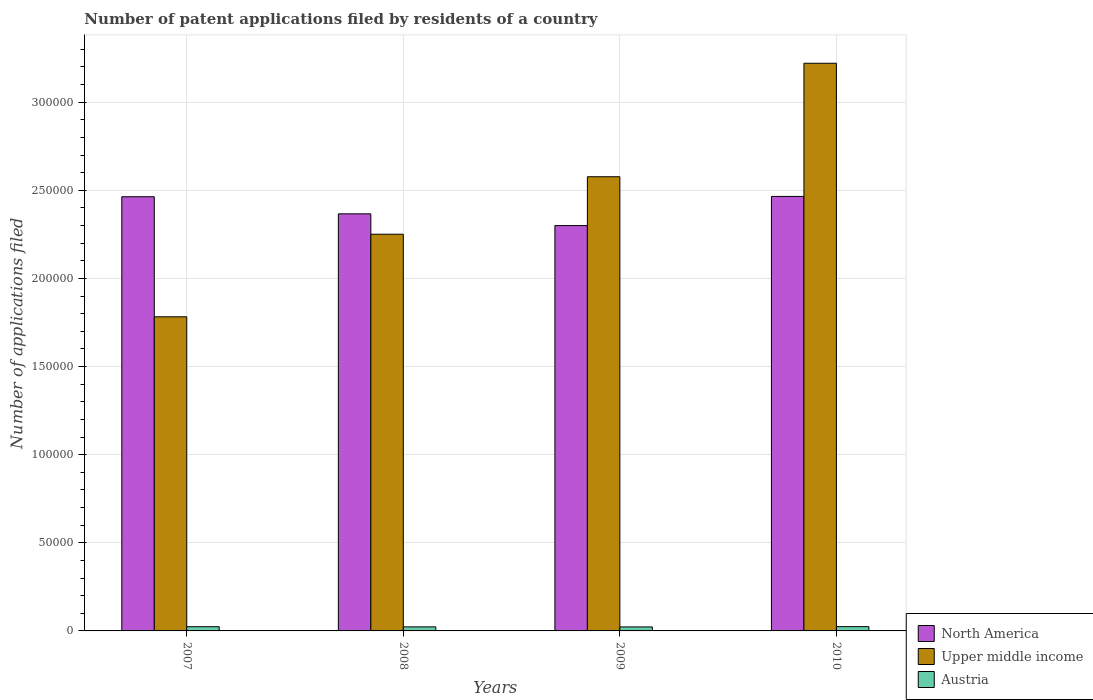Are the number of bars per tick equal to the number of legend labels?
Give a very brief answer. Yes. How many bars are there on the 3rd tick from the right?
Your answer should be compact. 3. What is the number of applications filed in Austria in 2008?
Make the answer very short. 2298. Across all years, what is the maximum number of applications filed in Austria?
Your answer should be compact. 2424. Across all years, what is the minimum number of applications filed in Upper middle income?
Ensure brevity in your answer.  1.78e+05. In which year was the number of applications filed in Austria minimum?
Keep it short and to the point. 2009. What is the total number of applications filed in Upper middle income in the graph?
Make the answer very short. 9.83e+05. What is the difference between the number of applications filed in Upper middle income in 2007 and that in 2010?
Give a very brief answer. -1.44e+05. What is the difference between the number of applications filed in Austria in 2008 and the number of applications filed in North America in 2009?
Ensure brevity in your answer.  -2.28e+05. What is the average number of applications filed in Upper middle income per year?
Provide a succinct answer. 2.46e+05. In the year 2008, what is the difference between the number of applications filed in Austria and number of applications filed in North America?
Provide a succinct answer. -2.34e+05. In how many years, is the number of applications filed in North America greater than 120000?
Give a very brief answer. 4. What is the ratio of the number of applications filed in Austria in 2008 to that in 2009?
Your answer should be very brief. 1.02. Is the number of applications filed in Austria in 2007 less than that in 2009?
Keep it short and to the point. No. What is the difference between the highest and the second highest number of applications filed in Austria?
Keep it short and to the point. 39. What is the difference between the highest and the lowest number of applications filed in Austria?
Your answer should be compact. 161. What does the 2nd bar from the left in 2010 represents?
Provide a succinct answer. Upper middle income. What does the 2nd bar from the right in 2007 represents?
Give a very brief answer. Upper middle income. Are all the bars in the graph horizontal?
Provide a succinct answer. No. What is the difference between two consecutive major ticks on the Y-axis?
Offer a very short reply. 5.00e+04. Are the values on the major ticks of Y-axis written in scientific E-notation?
Offer a very short reply. No. Does the graph contain grids?
Offer a terse response. Yes. Where does the legend appear in the graph?
Provide a short and direct response. Bottom right. What is the title of the graph?
Your answer should be very brief. Number of patent applications filed by residents of a country. Does "Uruguay" appear as one of the legend labels in the graph?
Provide a succinct answer. No. What is the label or title of the Y-axis?
Give a very brief answer. Number of applications filed. What is the Number of applications filed in North America in 2007?
Your answer should be compact. 2.46e+05. What is the Number of applications filed in Upper middle income in 2007?
Offer a terse response. 1.78e+05. What is the Number of applications filed of Austria in 2007?
Keep it short and to the point. 2385. What is the Number of applications filed of North America in 2008?
Offer a very short reply. 2.37e+05. What is the Number of applications filed of Upper middle income in 2008?
Your response must be concise. 2.25e+05. What is the Number of applications filed in Austria in 2008?
Keep it short and to the point. 2298. What is the Number of applications filed of North America in 2009?
Offer a very short reply. 2.30e+05. What is the Number of applications filed of Upper middle income in 2009?
Keep it short and to the point. 2.58e+05. What is the Number of applications filed in Austria in 2009?
Give a very brief answer. 2263. What is the Number of applications filed in North America in 2010?
Ensure brevity in your answer.  2.47e+05. What is the Number of applications filed in Upper middle income in 2010?
Your answer should be compact. 3.22e+05. What is the Number of applications filed of Austria in 2010?
Provide a succinct answer. 2424. Across all years, what is the maximum Number of applications filed in North America?
Make the answer very short. 2.47e+05. Across all years, what is the maximum Number of applications filed of Upper middle income?
Your answer should be very brief. 3.22e+05. Across all years, what is the maximum Number of applications filed in Austria?
Your answer should be very brief. 2424. Across all years, what is the minimum Number of applications filed in North America?
Your answer should be compact. 2.30e+05. Across all years, what is the minimum Number of applications filed of Upper middle income?
Provide a succinct answer. 1.78e+05. Across all years, what is the minimum Number of applications filed of Austria?
Your answer should be very brief. 2263. What is the total Number of applications filed in North America in the graph?
Make the answer very short. 9.60e+05. What is the total Number of applications filed of Upper middle income in the graph?
Your response must be concise. 9.83e+05. What is the total Number of applications filed of Austria in the graph?
Offer a terse response. 9370. What is the difference between the Number of applications filed of North America in 2007 and that in 2008?
Give a very brief answer. 9696. What is the difference between the Number of applications filed in Upper middle income in 2007 and that in 2008?
Your answer should be compact. -4.68e+04. What is the difference between the Number of applications filed of North America in 2007 and that in 2009?
Your answer should be very brief. 1.64e+04. What is the difference between the Number of applications filed in Upper middle income in 2007 and that in 2009?
Your answer should be very brief. -7.95e+04. What is the difference between the Number of applications filed in Austria in 2007 and that in 2009?
Provide a succinct answer. 122. What is the difference between the Number of applications filed in North America in 2007 and that in 2010?
Your answer should be very brief. -182. What is the difference between the Number of applications filed in Upper middle income in 2007 and that in 2010?
Your answer should be very brief. -1.44e+05. What is the difference between the Number of applications filed in Austria in 2007 and that in 2010?
Offer a very short reply. -39. What is the difference between the Number of applications filed in North America in 2008 and that in 2009?
Offer a very short reply. 6670. What is the difference between the Number of applications filed in Upper middle income in 2008 and that in 2009?
Your answer should be compact. -3.26e+04. What is the difference between the Number of applications filed of North America in 2008 and that in 2010?
Your response must be concise. -9878. What is the difference between the Number of applications filed of Upper middle income in 2008 and that in 2010?
Offer a terse response. -9.70e+04. What is the difference between the Number of applications filed of Austria in 2008 and that in 2010?
Offer a very short reply. -126. What is the difference between the Number of applications filed in North America in 2009 and that in 2010?
Your answer should be compact. -1.65e+04. What is the difference between the Number of applications filed in Upper middle income in 2009 and that in 2010?
Offer a terse response. -6.44e+04. What is the difference between the Number of applications filed of Austria in 2009 and that in 2010?
Offer a terse response. -161. What is the difference between the Number of applications filed of North America in 2007 and the Number of applications filed of Upper middle income in 2008?
Your answer should be very brief. 2.13e+04. What is the difference between the Number of applications filed of North America in 2007 and the Number of applications filed of Austria in 2008?
Provide a short and direct response. 2.44e+05. What is the difference between the Number of applications filed in Upper middle income in 2007 and the Number of applications filed in Austria in 2008?
Provide a short and direct response. 1.76e+05. What is the difference between the Number of applications filed of North America in 2007 and the Number of applications filed of Upper middle income in 2009?
Provide a short and direct response. -1.14e+04. What is the difference between the Number of applications filed in North America in 2007 and the Number of applications filed in Austria in 2009?
Give a very brief answer. 2.44e+05. What is the difference between the Number of applications filed in Upper middle income in 2007 and the Number of applications filed in Austria in 2009?
Keep it short and to the point. 1.76e+05. What is the difference between the Number of applications filed in North America in 2007 and the Number of applications filed in Upper middle income in 2010?
Provide a short and direct response. -7.57e+04. What is the difference between the Number of applications filed of North America in 2007 and the Number of applications filed of Austria in 2010?
Ensure brevity in your answer.  2.44e+05. What is the difference between the Number of applications filed of Upper middle income in 2007 and the Number of applications filed of Austria in 2010?
Give a very brief answer. 1.76e+05. What is the difference between the Number of applications filed of North America in 2008 and the Number of applications filed of Upper middle income in 2009?
Give a very brief answer. -2.10e+04. What is the difference between the Number of applications filed in North America in 2008 and the Number of applications filed in Austria in 2009?
Your response must be concise. 2.34e+05. What is the difference between the Number of applications filed of Upper middle income in 2008 and the Number of applications filed of Austria in 2009?
Make the answer very short. 2.23e+05. What is the difference between the Number of applications filed of North America in 2008 and the Number of applications filed of Upper middle income in 2010?
Provide a short and direct response. -8.54e+04. What is the difference between the Number of applications filed of North America in 2008 and the Number of applications filed of Austria in 2010?
Make the answer very short. 2.34e+05. What is the difference between the Number of applications filed in Upper middle income in 2008 and the Number of applications filed in Austria in 2010?
Keep it short and to the point. 2.23e+05. What is the difference between the Number of applications filed in North America in 2009 and the Number of applications filed in Upper middle income in 2010?
Your answer should be very brief. -9.21e+04. What is the difference between the Number of applications filed in North America in 2009 and the Number of applications filed in Austria in 2010?
Offer a very short reply. 2.28e+05. What is the difference between the Number of applications filed of Upper middle income in 2009 and the Number of applications filed of Austria in 2010?
Ensure brevity in your answer.  2.55e+05. What is the average Number of applications filed of North America per year?
Your response must be concise. 2.40e+05. What is the average Number of applications filed in Upper middle income per year?
Give a very brief answer. 2.46e+05. What is the average Number of applications filed of Austria per year?
Offer a terse response. 2342.5. In the year 2007, what is the difference between the Number of applications filed in North America and Number of applications filed in Upper middle income?
Offer a very short reply. 6.81e+04. In the year 2007, what is the difference between the Number of applications filed in North America and Number of applications filed in Austria?
Offer a very short reply. 2.44e+05. In the year 2007, what is the difference between the Number of applications filed in Upper middle income and Number of applications filed in Austria?
Provide a short and direct response. 1.76e+05. In the year 2008, what is the difference between the Number of applications filed in North America and Number of applications filed in Upper middle income?
Give a very brief answer. 1.16e+04. In the year 2008, what is the difference between the Number of applications filed in North America and Number of applications filed in Austria?
Provide a succinct answer. 2.34e+05. In the year 2008, what is the difference between the Number of applications filed in Upper middle income and Number of applications filed in Austria?
Your answer should be compact. 2.23e+05. In the year 2009, what is the difference between the Number of applications filed in North America and Number of applications filed in Upper middle income?
Keep it short and to the point. -2.77e+04. In the year 2009, what is the difference between the Number of applications filed in North America and Number of applications filed in Austria?
Provide a succinct answer. 2.28e+05. In the year 2009, what is the difference between the Number of applications filed of Upper middle income and Number of applications filed of Austria?
Make the answer very short. 2.55e+05. In the year 2010, what is the difference between the Number of applications filed in North America and Number of applications filed in Upper middle income?
Provide a short and direct response. -7.56e+04. In the year 2010, what is the difference between the Number of applications filed of North America and Number of applications filed of Austria?
Ensure brevity in your answer.  2.44e+05. In the year 2010, what is the difference between the Number of applications filed in Upper middle income and Number of applications filed in Austria?
Your answer should be very brief. 3.20e+05. What is the ratio of the Number of applications filed in North America in 2007 to that in 2008?
Offer a very short reply. 1.04. What is the ratio of the Number of applications filed of Upper middle income in 2007 to that in 2008?
Offer a terse response. 0.79. What is the ratio of the Number of applications filed of Austria in 2007 to that in 2008?
Ensure brevity in your answer.  1.04. What is the ratio of the Number of applications filed of North America in 2007 to that in 2009?
Provide a succinct answer. 1.07. What is the ratio of the Number of applications filed of Upper middle income in 2007 to that in 2009?
Offer a terse response. 0.69. What is the ratio of the Number of applications filed of Austria in 2007 to that in 2009?
Give a very brief answer. 1.05. What is the ratio of the Number of applications filed in Upper middle income in 2007 to that in 2010?
Offer a very short reply. 0.55. What is the ratio of the Number of applications filed in Austria in 2007 to that in 2010?
Ensure brevity in your answer.  0.98. What is the ratio of the Number of applications filed in Upper middle income in 2008 to that in 2009?
Your answer should be compact. 0.87. What is the ratio of the Number of applications filed in Austria in 2008 to that in 2009?
Your answer should be compact. 1.02. What is the ratio of the Number of applications filed of North America in 2008 to that in 2010?
Your response must be concise. 0.96. What is the ratio of the Number of applications filed in Upper middle income in 2008 to that in 2010?
Give a very brief answer. 0.7. What is the ratio of the Number of applications filed in Austria in 2008 to that in 2010?
Make the answer very short. 0.95. What is the ratio of the Number of applications filed of North America in 2009 to that in 2010?
Provide a short and direct response. 0.93. What is the ratio of the Number of applications filed of Upper middle income in 2009 to that in 2010?
Keep it short and to the point. 0.8. What is the ratio of the Number of applications filed in Austria in 2009 to that in 2010?
Your answer should be compact. 0.93. What is the difference between the highest and the second highest Number of applications filed in North America?
Ensure brevity in your answer.  182. What is the difference between the highest and the second highest Number of applications filed of Upper middle income?
Provide a short and direct response. 6.44e+04. What is the difference between the highest and the second highest Number of applications filed in Austria?
Provide a short and direct response. 39. What is the difference between the highest and the lowest Number of applications filed of North America?
Ensure brevity in your answer.  1.65e+04. What is the difference between the highest and the lowest Number of applications filed in Upper middle income?
Your response must be concise. 1.44e+05. What is the difference between the highest and the lowest Number of applications filed of Austria?
Your response must be concise. 161. 